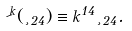<formula> <loc_0><loc_0><loc_500><loc_500>\psi ^ { k } ( \xi _ { 2 4 } ) \equiv k ^ { 1 4 } \xi _ { 2 4 } .</formula> 